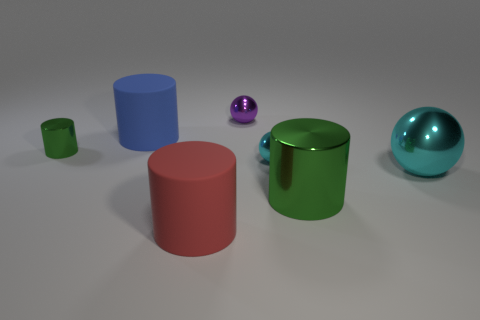Subtract all purple cylinders. Subtract all green blocks. How many cylinders are left? 4 Add 3 small green metal things. How many objects exist? 10 Subtract all spheres. How many objects are left? 4 Add 2 big green metallic cylinders. How many big green metallic cylinders are left? 3 Add 3 green things. How many green things exist? 5 Subtract 0 yellow cylinders. How many objects are left? 7 Subtract all yellow matte cylinders. Subtract all cyan spheres. How many objects are left? 5 